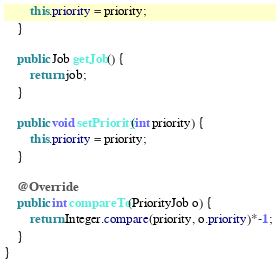Convert code to text. <code><loc_0><loc_0><loc_500><loc_500><_Java_>		this.priority = priority;
	}

	public Job getJob() {
		return job;
	}

	public void setPriority(int priority) {
		this.priority = priority;
	}

	@Override
	public int compareTo(PriorityJob o) {
		return Integer.compare(priority, o.priority)*-1;
	}
}
</code> 